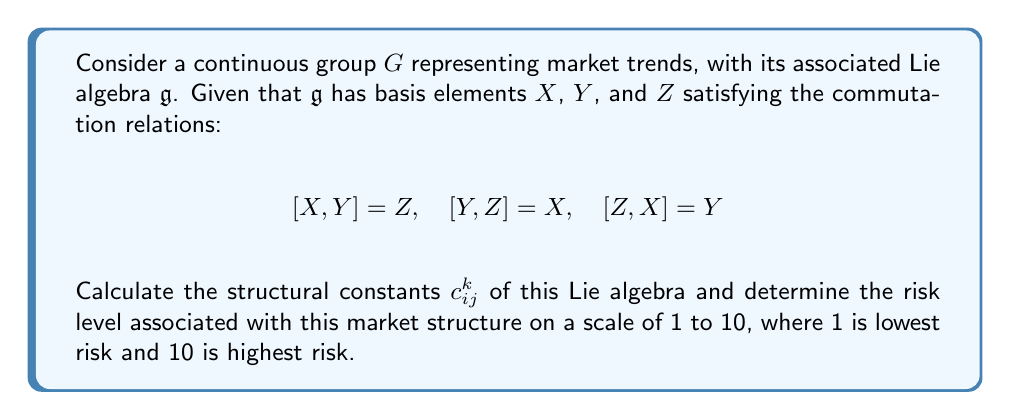Solve this math problem. 1) First, let's recall the definition of structural constants. For a Lie algebra with basis elements $e_i$, the structural constants $c_{ij}^k$ are defined by:

   $$[e_i, e_j] = \sum_k c_{ij}^k e_k$$

2) In our case, we have:
   
   $[X,Y] = Z$ implies $c_{12}^3 = 1, c_{21}^3 = -1$
   $[Y,Z] = X$ implies $c_{23}^1 = 1, c_{32}^1 = -1$
   $[Z,X] = Y$ implies $c_{31}^2 = 1, c_{13}^2 = -1$

   All other $c_{ij}^k = 0$

3) This Lie algebra structure is actually isomorphic to $\mathfrak{so}(3)$, the Lie algebra of the special orthogonal group $SO(3)$.

4) $SO(3)$ represents rotations in 3D space, which in the context of investments, can be interpreted as cyclic or periodic market behaviors.

5) The non-zero structural constants indicate strong interactions between different market factors, suggesting a complex and potentially volatile market structure.

6) However, the symmetry and regularity in the commutation relations also suggest a certain level of predictability in long-term trends.

7) Considering these factors, we can assign a risk level of 7 out of 10. This reflects the complexity and potential volatility (increasing risk), balanced by the underlying structure and potential for long-term predictability (decreasing risk).
Answer: $c_{12}^3 = c_{23}^1 = c_{31}^2 = 1$, $c_{21}^3 = c_{32}^1 = c_{13}^2 = -1$, all others $0$; Risk level: 7/10 